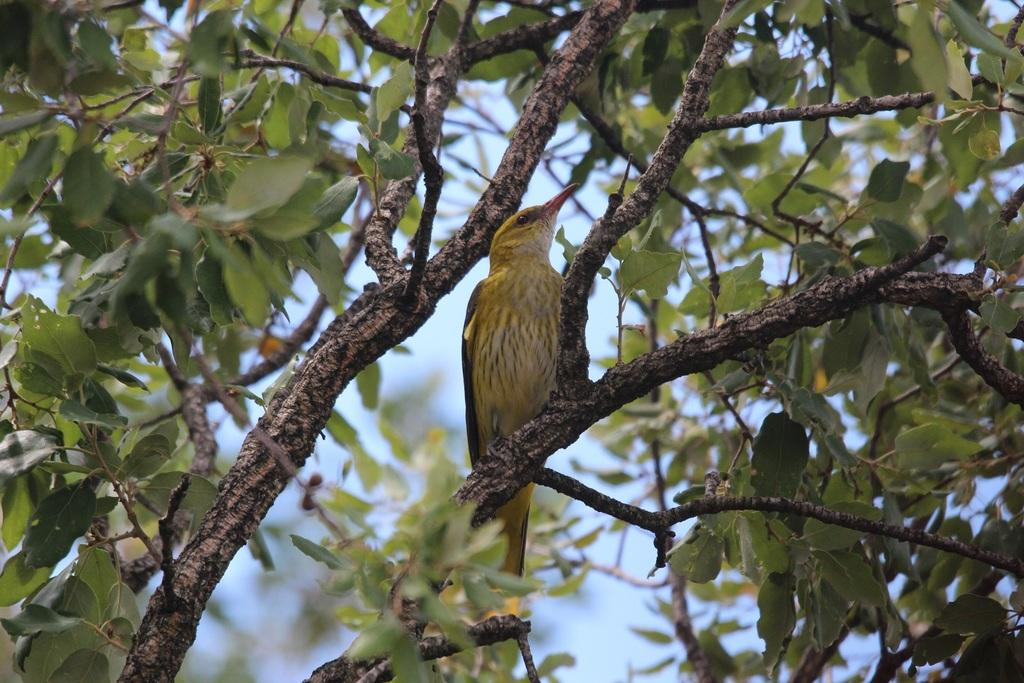What type of animal can be seen in the image? There is a bird in the image. Where is the bird located in the image? The bird is on the branch of a tree. What can be seen in the background of the image? There are leaves and the sky visible in the image. What type of payment method is being used by the bird in the image? There is no payment method being used by the bird in the image, as birds do not use payment methods. 